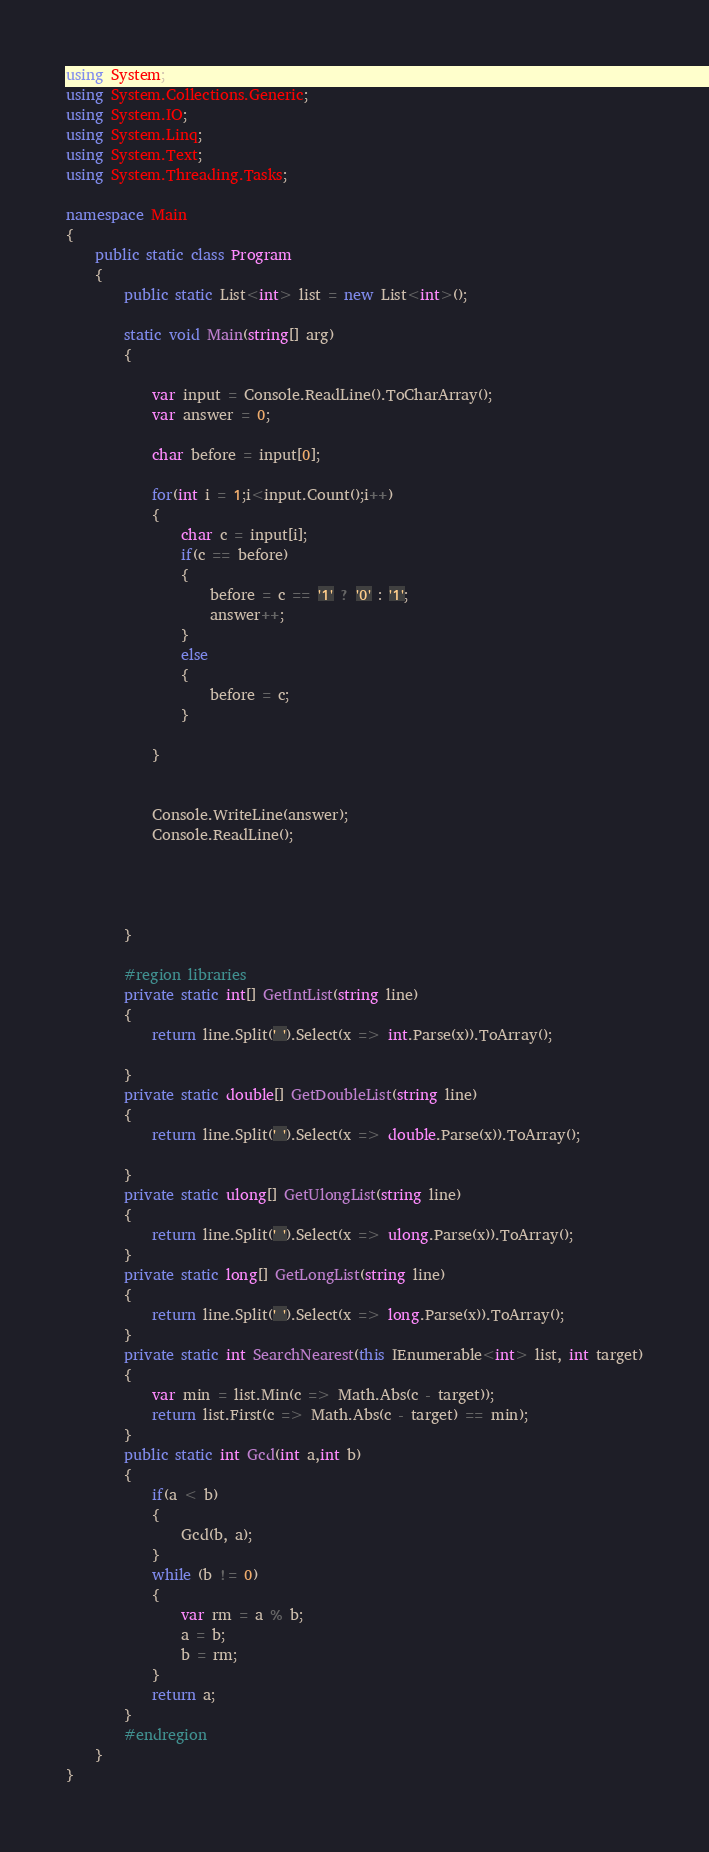Convert code to text. <code><loc_0><loc_0><loc_500><loc_500><_C#_>using System;
using System.Collections.Generic;
using System.IO;
using System.Linq;
using System.Text;
using System.Threading.Tasks;

namespace Main
{
    public static class Program
    {
        public static List<int> list = new List<int>();

        static void Main(string[] arg)
        {

            var input = Console.ReadLine().ToCharArray();
            var answer = 0;

            char before = input[0];

            for(int i = 1;i<input.Count();i++)
            {
                char c = input[i];
                if(c == before)
                {
                    before = c == '1' ? '0' : '1';
                    answer++;
                }
                else
                {
                    before = c;
                }
                
            }
            

            Console.WriteLine(answer);
            Console.ReadLine();




        }
        
        #region libraries
        private static int[] GetIntList(string line)
        {
            return line.Split(' ').Select(x => int.Parse(x)).ToArray();

        }
        private static double[] GetDoubleList(string line)
        {
            return line.Split(' ').Select(x => double.Parse(x)).ToArray();

        }
        private static ulong[] GetUlongList(string line)
        {
            return line.Split(' ').Select(x => ulong.Parse(x)).ToArray();
        }
        private static long[] GetLongList(string line)
        {
            return line.Split(' ').Select(x => long.Parse(x)).ToArray();
        }
        private static int SearchNearest(this IEnumerable<int> list, int target)
        {
            var min = list.Min(c => Math.Abs(c - target));
            return list.First(c => Math.Abs(c - target) == min);
        }
        public static int Gcd(int a,int b)
        {
            if(a < b)
            {
                Gcd(b, a);
            }
            while (b != 0)
            {
                var rm = a % b;
                a = b;
                b = rm;
            }
            return a;
        }
        #endregion
    }
}
</code> 